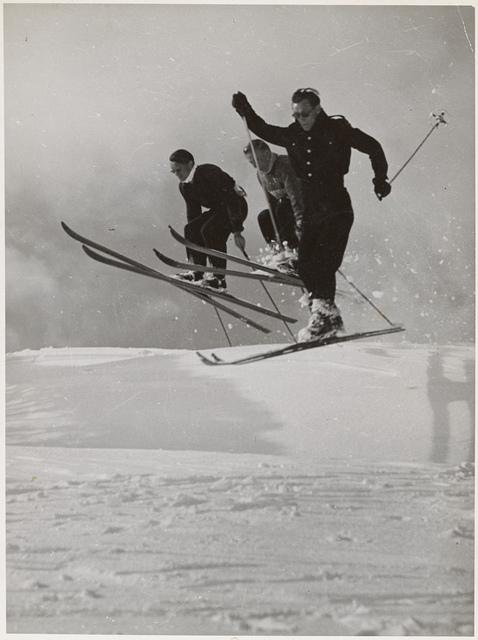Is the photo colored?
Give a very brief answer. No. How many ski poles do you see?
Answer briefly. 5. Are these skiers brave?
Write a very short answer. Yes. What sport are they playing?
Keep it brief. Skiing. 